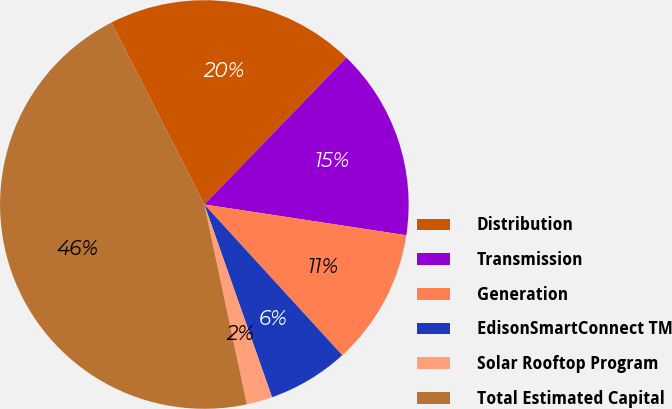<chart> <loc_0><loc_0><loc_500><loc_500><pie_chart><fcel>Distribution<fcel>Transmission<fcel>Generation<fcel>EdisonSmartConnect TM<fcel>Solar Rooftop Program<fcel>Total Estimated Capital<nl><fcel>19.75%<fcel>15.17%<fcel>10.8%<fcel>6.42%<fcel>2.04%<fcel>45.82%<nl></chart> 